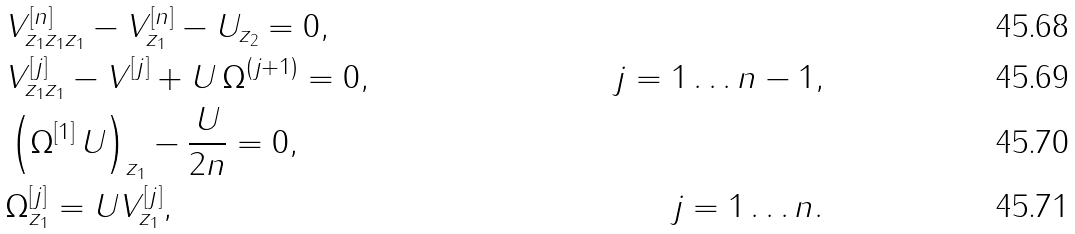Convert formula to latex. <formula><loc_0><loc_0><loc_500><loc_500>& V ^ { [ n ] } _ { z _ { 1 } z _ { 1 } z _ { 1 } } - V ^ { [ n ] } _ { z _ { 1 } } - U _ { z _ { 2 } } = 0 , & \\ & V ^ { [ j ] } _ { z _ { 1 } z _ { 1 } } - V ^ { [ j ] } + U \, \Omega ^ { ( j + 1 ) } = 0 , & j = 1 \dots n - 1 , \\ & \left ( \Omega ^ { [ 1 ] } \, U \right ) _ { z _ { 1 } } - \frac { U } { 2 n } = 0 , & \\ & \Omega ^ { [ j ] } _ { z _ { 1 } } = U V ^ { [ j ] } _ { z _ { 1 } } , & j = 1 \dots n .</formula> 